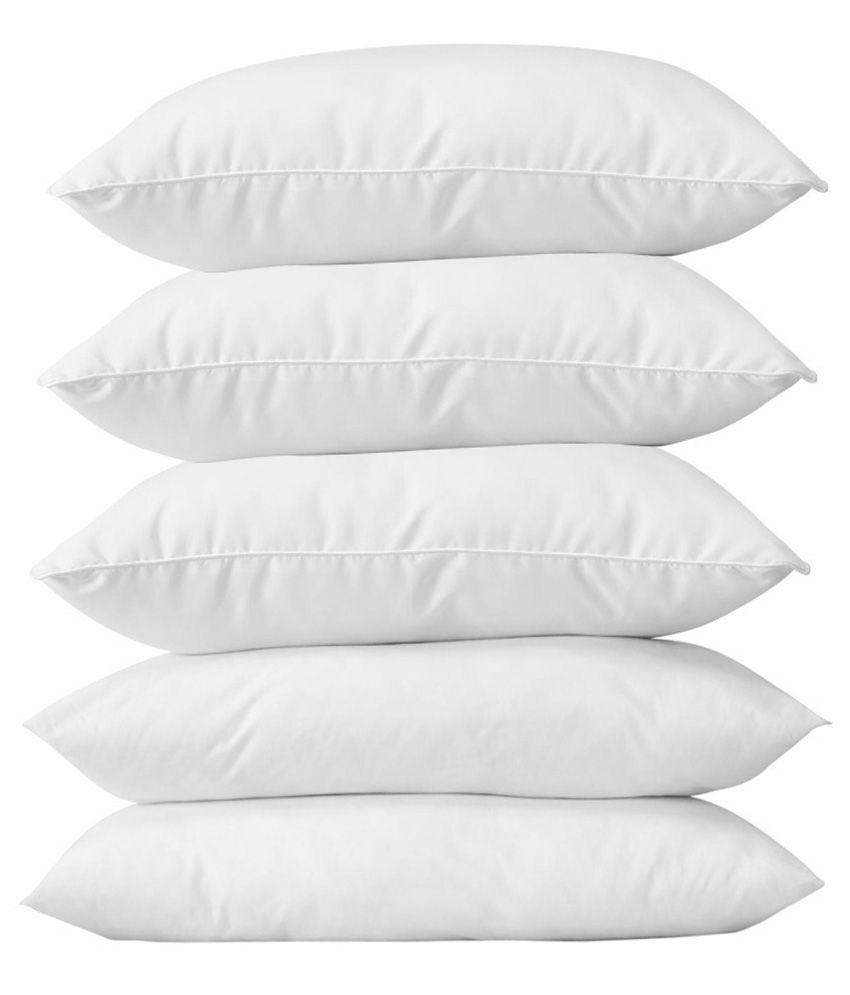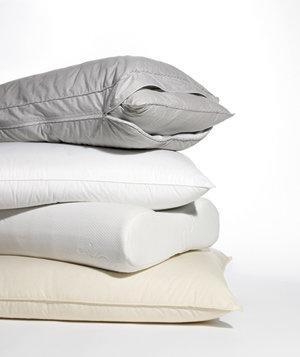The first image is the image on the left, the second image is the image on the right. Given the left and right images, does the statement "The left image contains a vertical stack of exactly four pillows." hold true? Answer yes or no. No. The first image is the image on the left, the second image is the image on the right. For the images displayed, is the sentence "There are two stacks of four pillows." factually correct? Answer yes or no. No. 